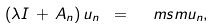Convert formula to latex. <formula><loc_0><loc_0><loc_500><loc_500>( \lambda I \, + \, A _ { n } ) \, { u } _ { n } \ = \ \ m s m u _ { n } ,</formula> 